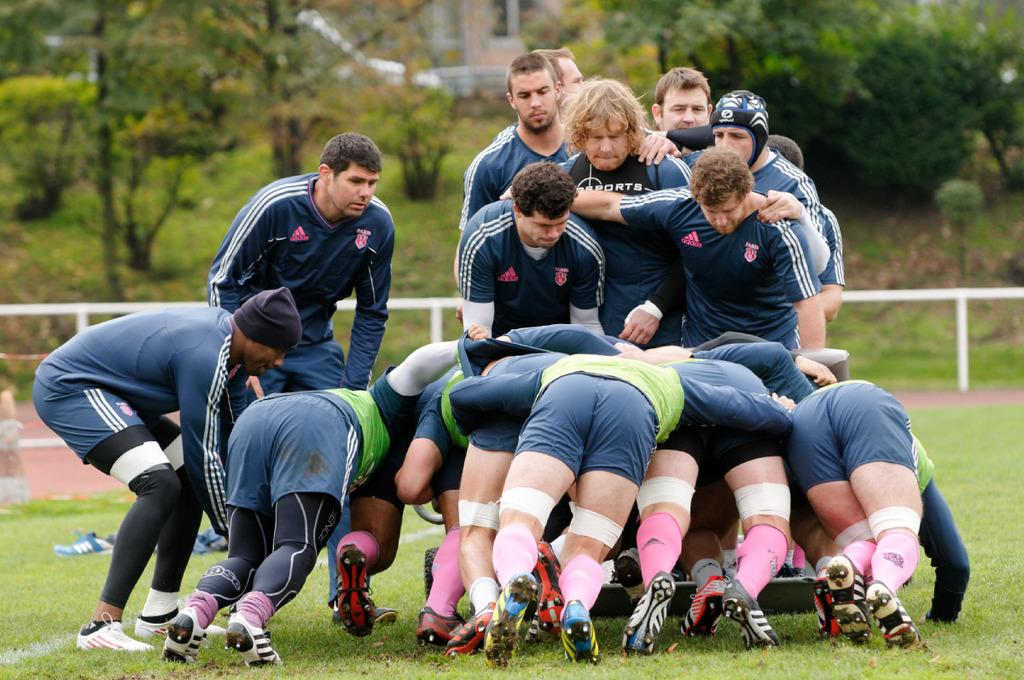What are the people in the image standing on? The people in the image are standing on the grass. What type of vegetation can be seen in the image? There are trees in the image. What type of structures are visible in the image? There are buildings in the image. What is the condition of the sky in the image? The sky is clear in the image. How many cats are sitting on the unit in the image? There are no cats or units present in the image. 